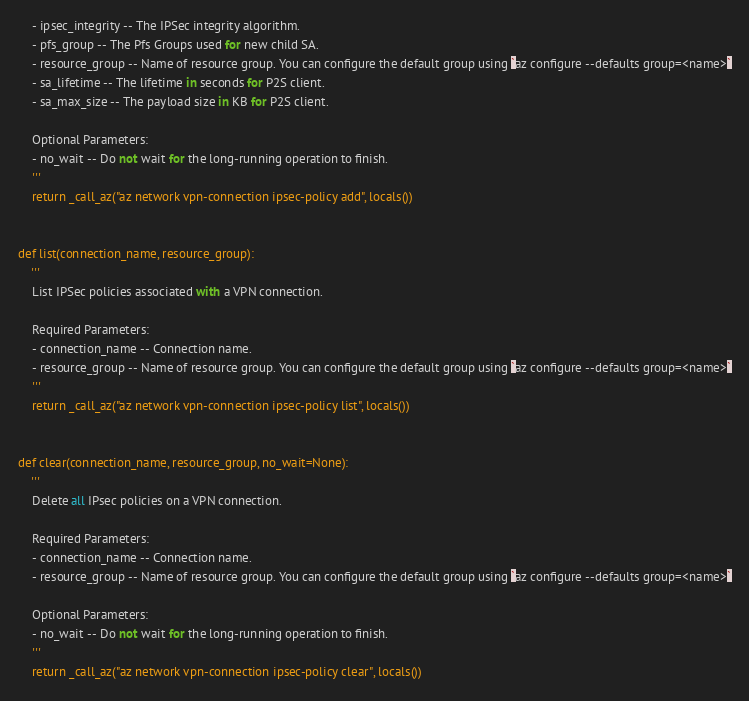<code> <loc_0><loc_0><loc_500><loc_500><_Python_>    - ipsec_integrity -- The IPSec integrity algorithm.
    - pfs_group -- The Pfs Groups used for new child SA.
    - resource_group -- Name of resource group. You can configure the default group using `az configure --defaults group=<name>`
    - sa_lifetime -- The lifetime in seconds for P2S client.
    - sa_max_size -- The payload size in KB for P2S client.

    Optional Parameters:
    - no_wait -- Do not wait for the long-running operation to finish.
    '''
    return _call_az("az network vpn-connection ipsec-policy add", locals())


def list(connection_name, resource_group):
    '''
    List IPSec policies associated with a VPN connection.

    Required Parameters:
    - connection_name -- Connection name.
    - resource_group -- Name of resource group. You can configure the default group using `az configure --defaults group=<name>`
    '''
    return _call_az("az network vpn-connection ipsec-policy list", locals())


def clear(connection_name, resource_group, no_wait=None):
    '''
    Delete all IPsec policies on a VPN connection.

    Required Parameters:
    - connection_name -- Connection name.
    - resource_group -- Name of resource group. You can configure the default group using `az configure --defaults group=<name>`

    Optional Parameters:
    - no_wait -- Do not wait for the long-running operation to finish.
    '''
    return _call_az("az network vpn-connection ipsec-policy clear", locals())

</code> 